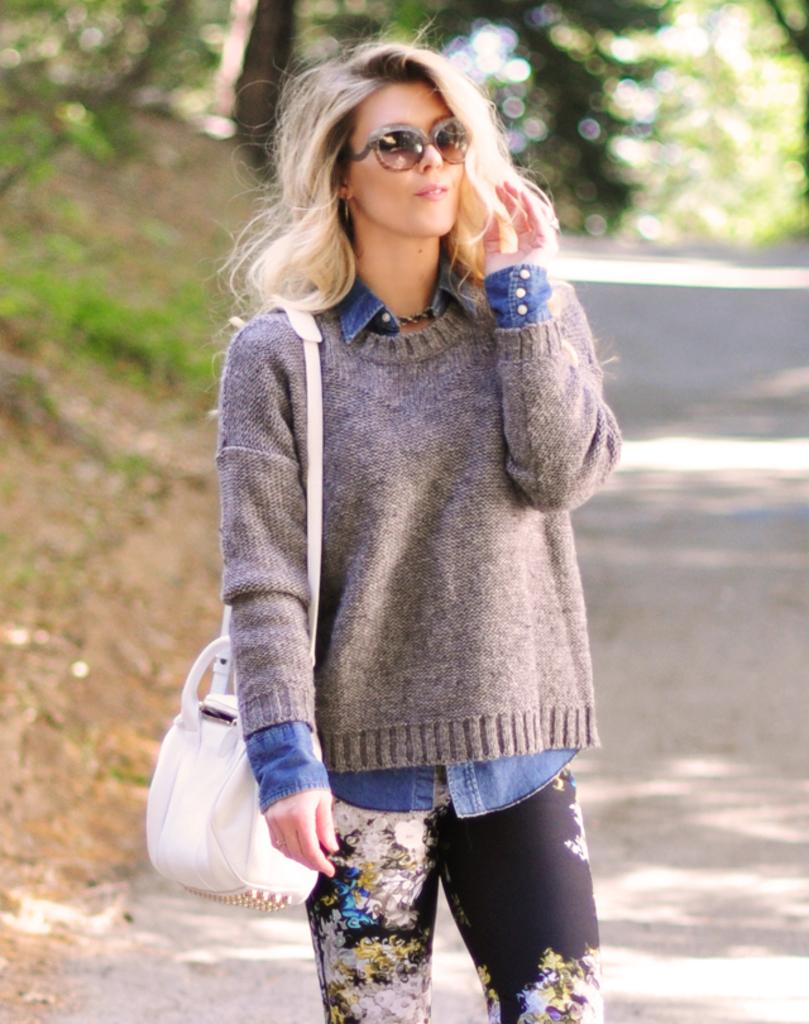Who is the main subject in the image? There is a woman in the image. What is the woman wearing on her upper body? The woman is wearing a sweater. What color are the pants the woman is wearing? The woman is wearing black pants. What is the woman carrying in the image? The woman is carrying a white bag. What can be seen in the background of the image? There is a road and trees visible in the background of the image. What type of card is the woman holding in the image? There is no card visible in the image; the woman is carrying a white bag. What type of lace can be seen on the woman's sweater in the image? There is no lace visible on the woman's sweater in the image; it is a sweater is described as a solid color. 